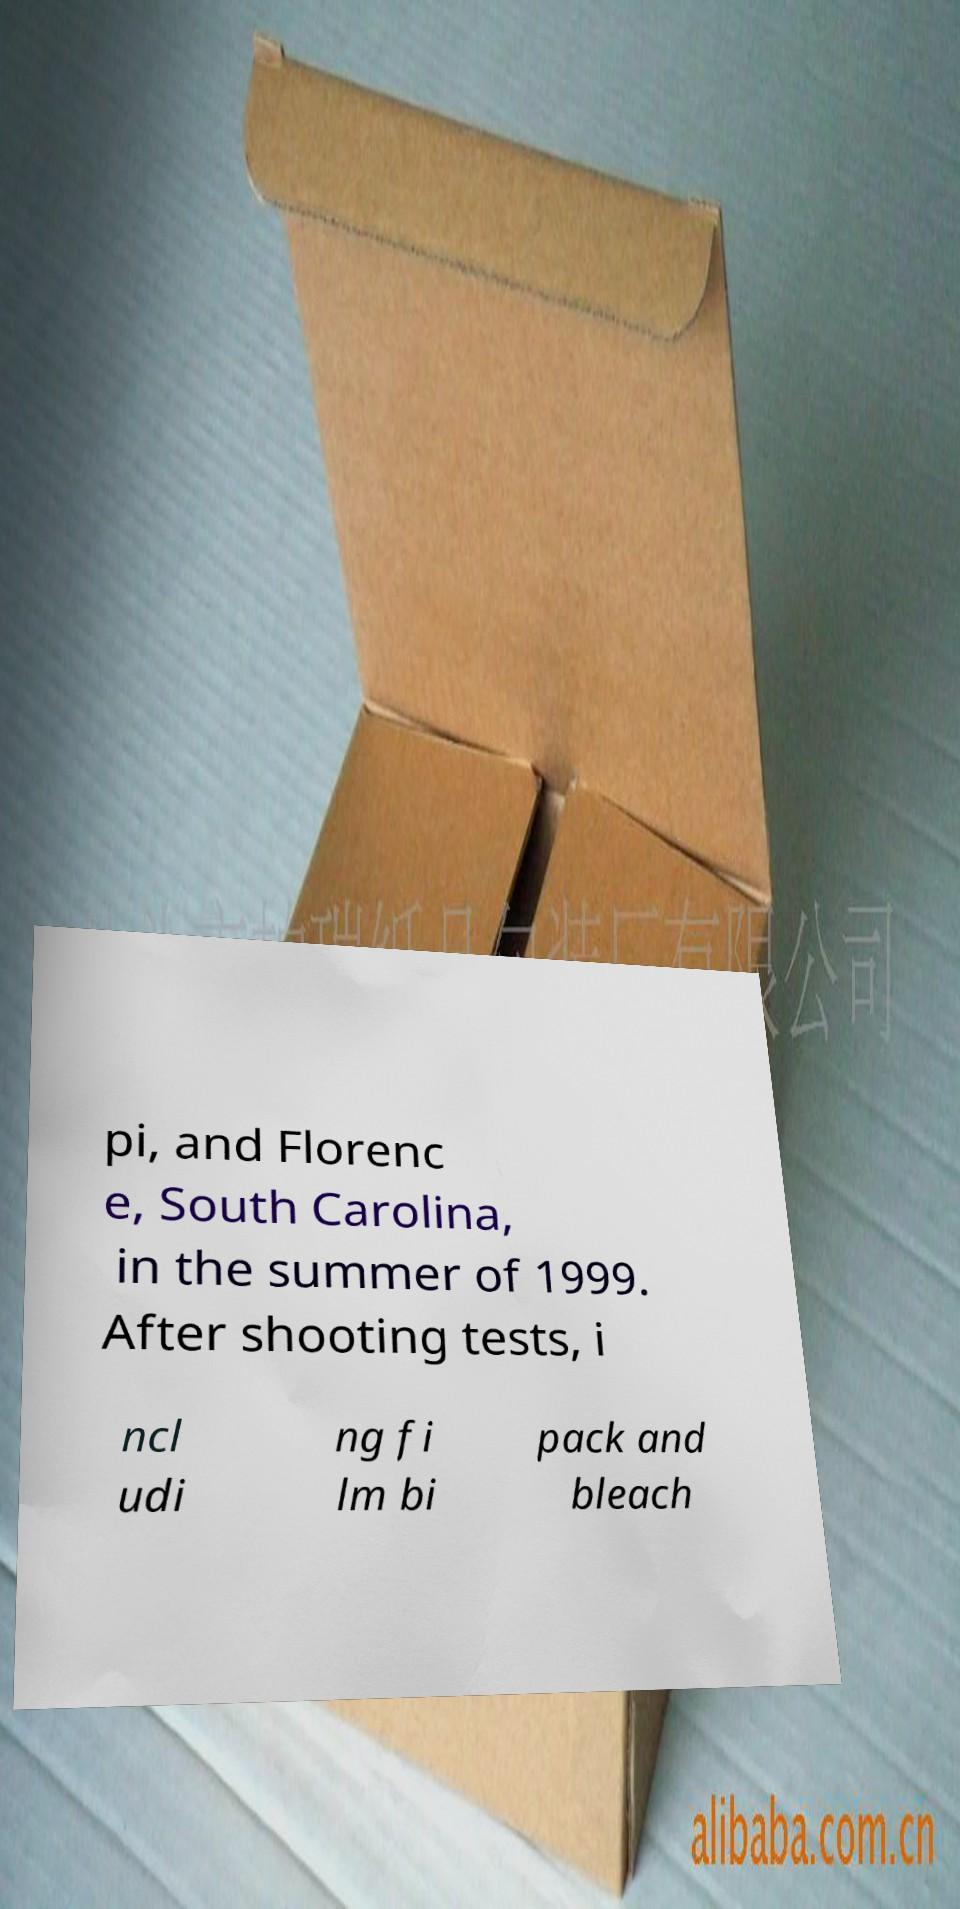What messages or text are displayed in this image? I need them in a readable, typed format. pi, and Florenc e, South Carolina, in the summer of 1999. After shooting tests, i ncl udi ng fi lm bi pack and bleach 